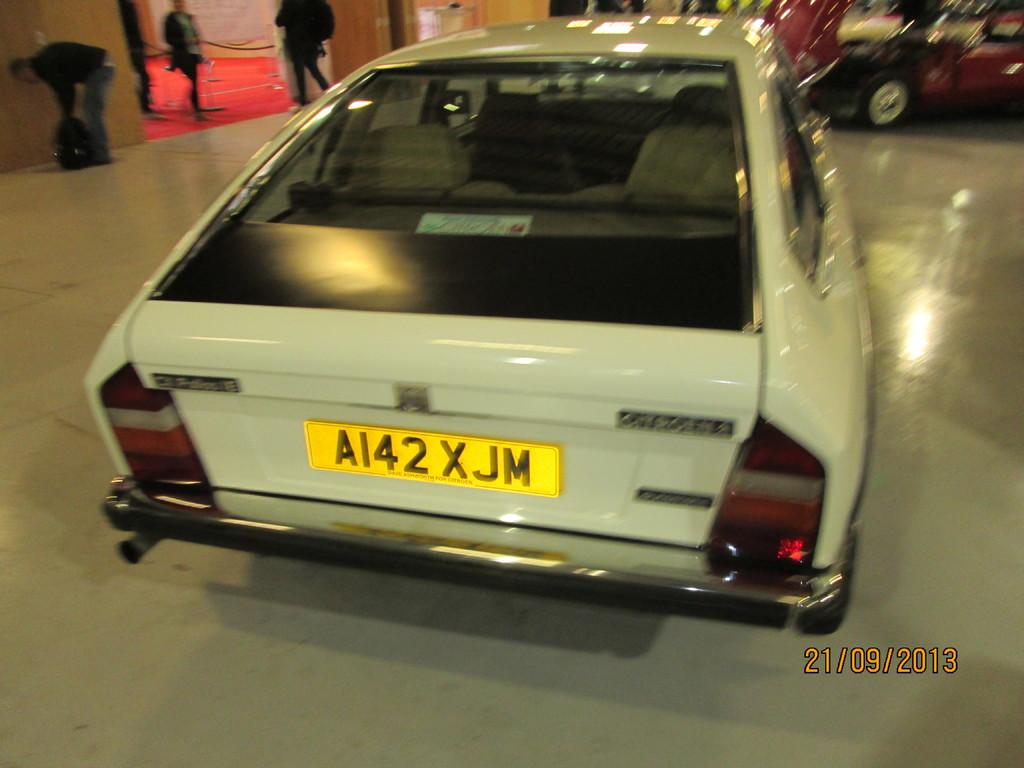What types of objects can be seen in the image? There are vehicles in the image. Are there any living beings present in the image? Yes, there are people in the image. Can you describe the background of the image? The background of the image is blurred. What type of needle is being used by the people in the image? There is no needle present in the image. What is the average income of the people in the image? The provided facts do not give any information about the income of the people in the image. 